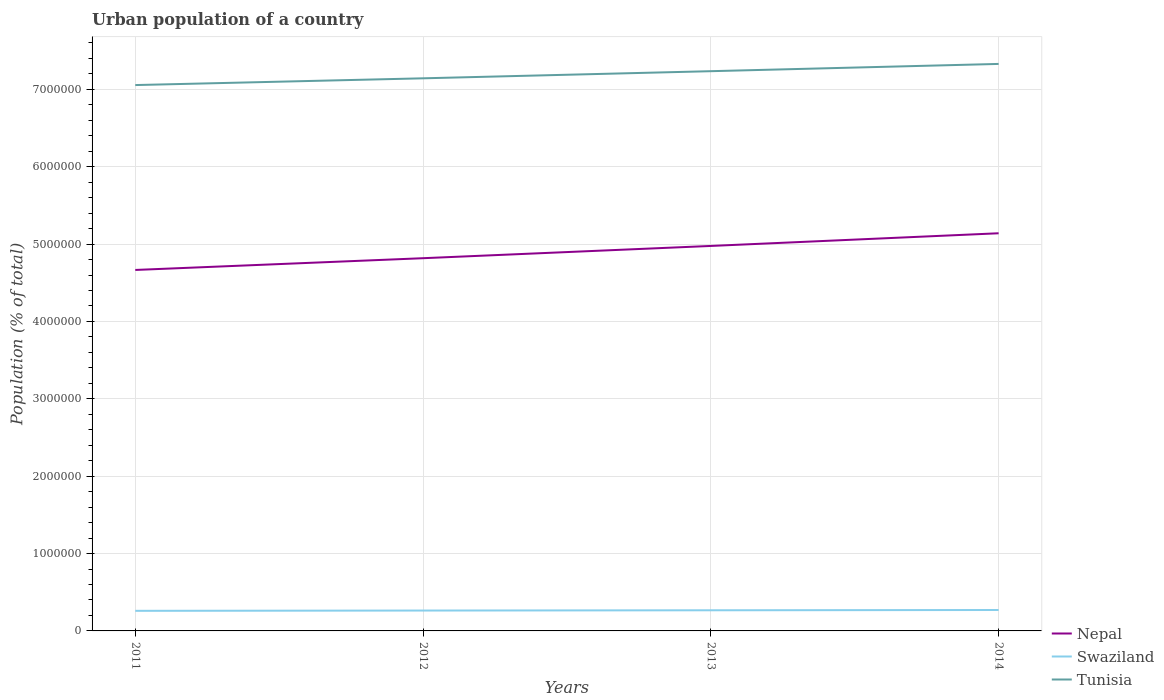How many different coloured lines are there?
Your answer should be compact. 3. Does the line corresponding to Tunisia intersect with the line corresponding to Nepal?
Provide a short and direct response. No. Across all years, what is the maximum urban population in Swaziland?
Keep it short and to the point. 2.60e+05. In which year was the urban population in Nepal maximum?
Your answer should be very brief. 2011. What is the total urban population in Tunisia in the graph?
Offer a very short reply. -1.79e+05. What is the difference between the highest and the second highest urban population in Nepal?
Provide a succinct answer. 4.74e+05. What is the difference between the highest and the lowest urban population in Tunisia?
Your answer should be very brief. 2. How many lines are there?
Your answer should be compact. 3. How many years are there in the graph?
Ensure brevity in your answer.  4. What is the difference between two consecutive major ticks on the Y-axis?
Your response must be concise. 1.00e+06. Does the graph contain any zero values?
Your answer should be very brief. No. How many legend labels are there?
Give a very brief answer. 3. What is the title of the graph?
Ensure brevity in your answer.  Urban population of a country. What is the label or title of the X-axis?
Ensure brevity in your answer.  Years. What is the label or title of the Y-axis?
Offer a terse response. Population (% of total). What is the Population (% of total) of Nepal in 2011?
Provide a short and direct response. 4.67e+06. What is the Population (% of total) in Swaziland in 2011?
Offer a very short reply. 2.60e+05. What is the Population (% of total) in Tunisia in 2011?
Your answer should be compact. 7.06e+06. What is the Population (% of total) of Nepal in 2012?
Provide a succinct answer. 4.82e+06. What is the Population (% of total) in Swaziland in 2012?
Offer a very short reply. 2.63e+05. What is the Population (% of total) of Tunisia in 2012?
Your response must be concise. 7.14e+06. What is the Population (% of total) of Nepal in 2013?
Your response must be concise. 4.98e+06. What is the Population (% of total) in Swaziland in 2013?
Offer a terse response. 2.67e+05. What is the Population (% of total) in Tunisia in 2013?
Make the answer very short. 7.23e+06. What is the Population (% of total) of Nepal in 2014?
Your answer should be compact. 5.14e+06. What is the Population (% of total) of Swaziland in 2014?
Your answer should be compact. 2.71e+05. What is the Population (% of total) in Tunisia in 2014?
Your answer should be very brief. 7.33e+06. Across all years, what is the maximum Population (% of total) in Nepal?
Your response must be concise. 5.14e+06. Across all years, what is the maximum Population (% of total) in Swaziland?
Your answer should be very brief. 2.71e+05. Across all years, what is the maximum Population (% of total) in Tunisia?
Provide a succinct answer. 7.33e+06. Across all years, what is the minimum Population (% of total) of Nepal?
Keep it short and to the point. 4.67e+06. Across all years, what is the minimum Population (% of total) in Swaziland?
Your response must be concise. 2.60e+05. Across all years, what is the minimum Population (% of total) in Tunisia?
Keep it short and to the point. 7.06e+06. What is the total Population (% of total) of Nepal in the graph?
Your answer should be very brief. 1.96e+07. What is the total Population (% of total) of Swaziland in the graph?
Ensure brevity in your answer.  1.06e+06. What is the total Population (% of total) of Tunisia in the graph?
Offer a very short reply. 2.88e+07. What is the difference between the Population (% of total) of Nepal in 2011 and that in 2012?
Offer a terse response. -1.52e+05. What is the difference between the Population (% of total) of Swaziland in 2011 and that in 2012?
Provide a short and direct response. -3493. What is the difference between the Population (% of total) of Tunisia in 2011 and that in 2012?
Your response must be concise. -8.73e+04. What is the difference between the Population (% of total) in Nepal in 2011 and that in 2013?
Ensure brevity in your answer.  -3.10e+05. What is the difference between the Population (% of total) of Swaziland in 2011 and that in 2013?
Your answer should be compact. -7080. What is the difference between the Population (% of total) of Tunisia in 2011 and that in 2013?
Your answer should be compact. -1.79e+05. What is the difference between the Population (% of total) in Nepal in 2011 and that in 2014?
Your answer should be compact. -4.74e+05. What is the difference between the Population (% of total) in Swaziland in 2011 and that in 2014?
Provide a succinct answer. -1.07e+04. What is the difference between the Population (% of total) of Tunisia in 2011 and that in 2014?
Your answer should be very brief. -2.73e+05. What is the difference between the Population (% of total) in Nepal in 2012 and that in 2013?
Your response must be concise. -1.59e+05. What is the difference between the Population (% of total) of Swaziland in 2012 and that in 2013?
Your response must be concise. -3587. What is the difference between the Population (% of total) of Tunisia in 2012 and that in 2013?
Offer a very short reply. -9.21e+04. What is the difference between the Population (% of total) of Nepal in 2012 and that in 2014?
Offer a very short reply. -3.22e+05. What is the difference between the Population (% of total) in Swaziland in 2012 and that in 2014?
Make the answer very short. -7249. What is the difference between the Population (% of total) of Tunisia in 2012 and that in 2014?
Make the answer very short. -1.86e+05. What is the difference between the Population (% of total) of Nepal in 2013 and that in 2014?
Your answer should be compact. -1.64e+05. What is the difference between the Population (% of total) of Swaziland in 2013 and that in 2014?
Keep it short and to the point. -3662. What is the difference between the Population (% of total) in Tunisia in 2013 and that in 2014?
Offer a terse response. -9.40e+04. What is the difference between the Population (% of total) of Nepal in 2011 and the Population (% of total) of Swaziland in 2012?
Offer a very short reply. 4.40e+06. What is the difference between the Population (% of total) in Nepal in 2011 and the Population (% of total) in Tunisia in 2012?
Provide a succinct answer. -2.48e+06. What is the difference between the Population (% of total) in Swaziland in 2011 and the Population (% of total) in Tunisia in 2012?
Give a very brief answer. -6.88e+06. What is the difference between the Population (% of total) of Nepal in 2011 and the Population (% of total) of Swaziland in 2013?
Give a very brief answer. 4.40e+06. What is the difference between the Population (% of total) in Nepal in 2011 and the Population (% of total) in Tunisia in 2013?
Offer a terse response. -2.57e+06. What is the difference between the Population (% of total) in Swaziland in 2011 and the Population (% of total) in Tunisia in 2013?
Offer a very short reply. -6.97e+06. What is the difference between the Population (% of total) in Nepal in 2011 and the Population (% of total) in Swaziland in 2014?
Provide a short and direct response. 4.40e+06. What is the difference between the Population (% of total) of Nepal in 2011 and the Population (% of total) of Tunisia in 2014?
Offer a very short reply. -2.66e+06. What is the difference between the Population (% of total) in Swaziland in 2011 and the Population (% of total) in Tunisia in 2014?
Make the answer very short. -7.07e+06. What is the difference between the Population (% of total) of Nepal in 2012 and the Population (% of total) of Swaziland in 2013?
Your answer should be very brief. 4.55e+06. What is the difference between the Population (% of total) of Nepal in 2012 and the Population (% of total) of Tunisia in 2013?
Offer a very short reply. -2.42e+06. What is the difference between the Population (% of total) of Swaziland in 2012 and the Population (% of total) of Tunisia in 2013?
Your answer should be very brief. -6.97e+06. What is the difference between the Population (% of total) of Nepal in 2012 and the Population (% of total) of Swaziland in 2014?
Provide a succinct answer. 4.55e+06. What is the difference between the Population (% of total) in Nepal in 2012 and the Population (% of total) in Tunisia in 2014?
Ensure brevity in your answer.  -2.51e+06. What is the difference between the Population (% of total) in Swaziland in 2012 and the Population (% of total) in Tunisia in 2014?
Provide a short and direct response. -7.07e+06. What is the difference between the Population (% of total) of Nepal in 2013 and the Population (% of total) of Swaziland in 2014?
Offer a terse response. 4.71e+06. What is the difference between the Population (% of total) of Nepal in 2013 and the Population (% of total) of Tunisia in 2014?
Provide a succinct answer. -2.35e+06. What is the difference between the Population (% of total) in Swaziland in 2013 and the Population (% of total) in Tunisia in 2014?
Provide a short and direct response. -7.06e+06. What is the average Population (% of total) in Nepal per year?
Provide a succinct answer. 4.90e+06. What is the average Population (% of total) of Swaziland per year?
Provide a succinct answer. 2.65e+05. What is the average Population (% of total) of Tunisia per year?
Keep it short and to the point. 7.19e+06. In the year 2011, what is the difference between the Population (% of total) of Nepal and Population (% of total) of Swaziland?
Provide a succinct answer. 4.41e+06. In the year 2011, what is the difference between the Population (% of total) of Nepal and Population (% of total) of Tunisia?
Keep it short and to the point. -2.39e+06. In the year 2011, what is the difference between the Population (% of total) of Swaziland and Population (% of total) of Tunisia?
Provide a succinct answer. -6.80e+06. In the year 2012, what is the difference between the Population (% of total) of Nepal and Population (% of total) of Swaziland?
Offer a very short reply. 4.55e+06. In the year 2012, what is the difference between the Population (% of total) in Nepal and Population (% of total) in Tunisia?
Provide a short and direct response. -2.33e+06. In the year 2012, what is the difference between the Population (% of total) of Swaziland and Population (% of total) of Tunisia?
Provide a short and direct response. -6.88e+06. In the year 2013, what is the difference between the Population (% of total) in Nepal and Population (% of total) in Swaziland?
Your answer should be compact. 4.71e+06. In the year 2013, what is the difference between the Population (% of total) of Nepal and Population (% of total) of Tunisia?
Offer a very short reply. -2.26e+06. In the year 2013, what is the difference between the Population (% of total) in Swaziland and Population (% of total) in Tunisia?
Provide a short and direct response. -6.97e+06. In the year 2014, what is the difference between the Population (% of total) in Nepal and Population (% of total) in Swaziland?
Keep it short and to the point. 4.87e+06. In the year 2014, what is the difference between the Population (% of total) in Nepal and Population (% of total) in Tunisia?
Your response must be concise. -2.19e+06. In the year 2014, what is the difference between the Population (% of total) in Swaziland and Population (% of total) in Tunisia?
Provide a succinct answer. -7.06e+06. What is the ratio of the Population (% of total) of Nepal in 2011 to that in 2012?
Give a very brief answer. 0.97. What is the ratio of the Population (% of total) of Swaziland in 2011 to that in 2012?
Your answer should be compact. 0.99. What is the ratio of the Population (% of total) of Nepal in 2011 to that in 2013?
Provide a short and direct response. 0.94. What is the ratio of the Population (% of total) of Swaziland in 2011 to that in 2013?
Offer a very short reply. 0.97. What is the ratio of the Population (% of total) of Tunisia in 2011 to that in 2013?
Your answer should be compact. 0.98. What is the ratio of the Population (% of total) in Nepal in 2011 to that in 2014?
Offer a very short reply. 0.91. What is the ratio of the Population (% of total) of Swaziland in 2011 to that in 2014?
Provide a succinct answer. 0.96. What is the ratio of the Population (% of total) in Tunisia in 2011 to that in 2014?
Ensure brevity in your answer.  0.96. What is the ratio of the Population (% of total) of Nepal in 2012 to that in 2013?
Provide a short and direct response. 0.97. What is the ratio of the Population (% of total) of Swaziland in 2012 to that in 2013?
Give a very brief answer. 0.99. What is the ratio of the Population (% of total) of Tunisia in 2012 to that in 2013?
Your response must be concise. 0.99. What is the ratio of the Population (% of total) in Nepal in 2012 to that in 2014?
Keep it short and to the point. 0.94. What is the ratio of the Population (% of total) of Swaziland in 2012 to that in 2014?
Ensure brevity in your answer.  0.97. What is the ratio of the Population (% of total) of Tunisia in 2012 to that in 2014?
Ensure brevity in your answer.  0.97. What is the ratio of the Population (% of total) in Nepal in 2013 to that in 2014?
Make the answer very short. 0.97. What is the ratio of the Population (% of total) of Swaziland in 2013 to that in 2014?
Provide a short and direct response. 0.99. What is the ratio of the Population (% of total) of Tunisia in 2013 to that in 2014?
Provide a short and direct response. 0.99. What is the difference between the highest and the second highest Population (% of total) in Nepal?
Provide a succinct answer. 1.64e+05. What is the difference between the highest and the second highest Population (% of total) in Swaziland?
Ensure brevity in your answer.  3662. What is the difference between the highest and the second highest Population (% of total) in Tunisia?
Your response must be concise. 9.40e+04. What is the difference between the highest and the lowest Population (% of total) in Nepal?
Your response must be concise. 4.74e+05. What is the difference between the highest and the lowest Population (% of total) of Swaziland?
Provide a succinct answer. 1.07e+04. What is the difference between the highest and the lowest Population (% of total) of Tunisia?
Your answer should be compact. 2.73e+05. 